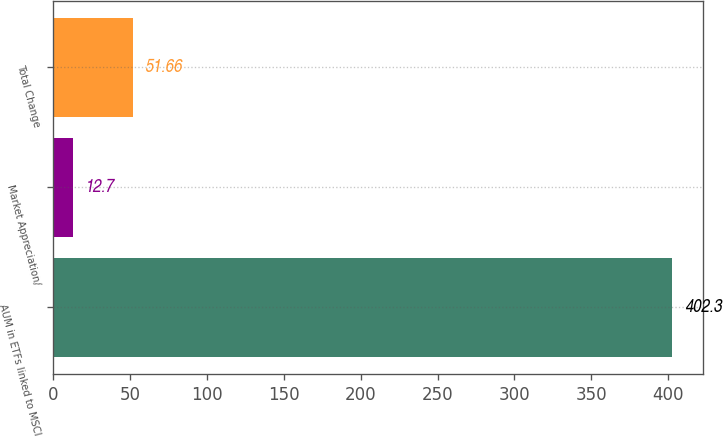Convert chart to OTSL. <chart><loc_0><loc_0><loc_500><loc_500><bar_chart><fcel>AUM in ETFs linked to MSCI<fcel>Market Appreciation/<fcel>Total Change<nl><fcel>402.3<fcel>12.7<fcel>51.66<nl></chart> 